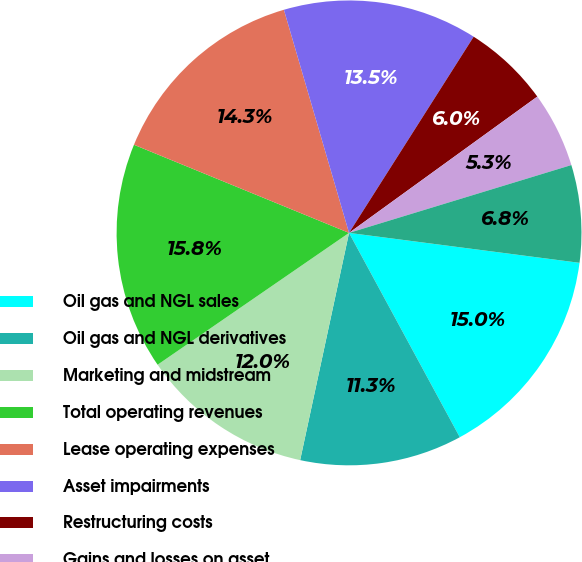Convert chart. <chart><loc_0><loc_0><loc_500><loc_500><pie_chart><fcel>Oil gas and NGL sales<fcel>Oil gas and NGL derivatives<fcel>Marketing and midstream<fcel>Total operating revenues<fcel>Lease operating expenses<fcel>Asset impairments<fcel>Restructuring costs<fcel>Gains and losses on asset<fcel>Other operating items<nl><fcel>15.04%<fcel>11.28%<fcel>12.03%<fcel>15.79%<fcel>14.29%<fcel>13.53%<fcel>6.02%<fcel>5.26%<fcel>6.77%<nl></chart> 